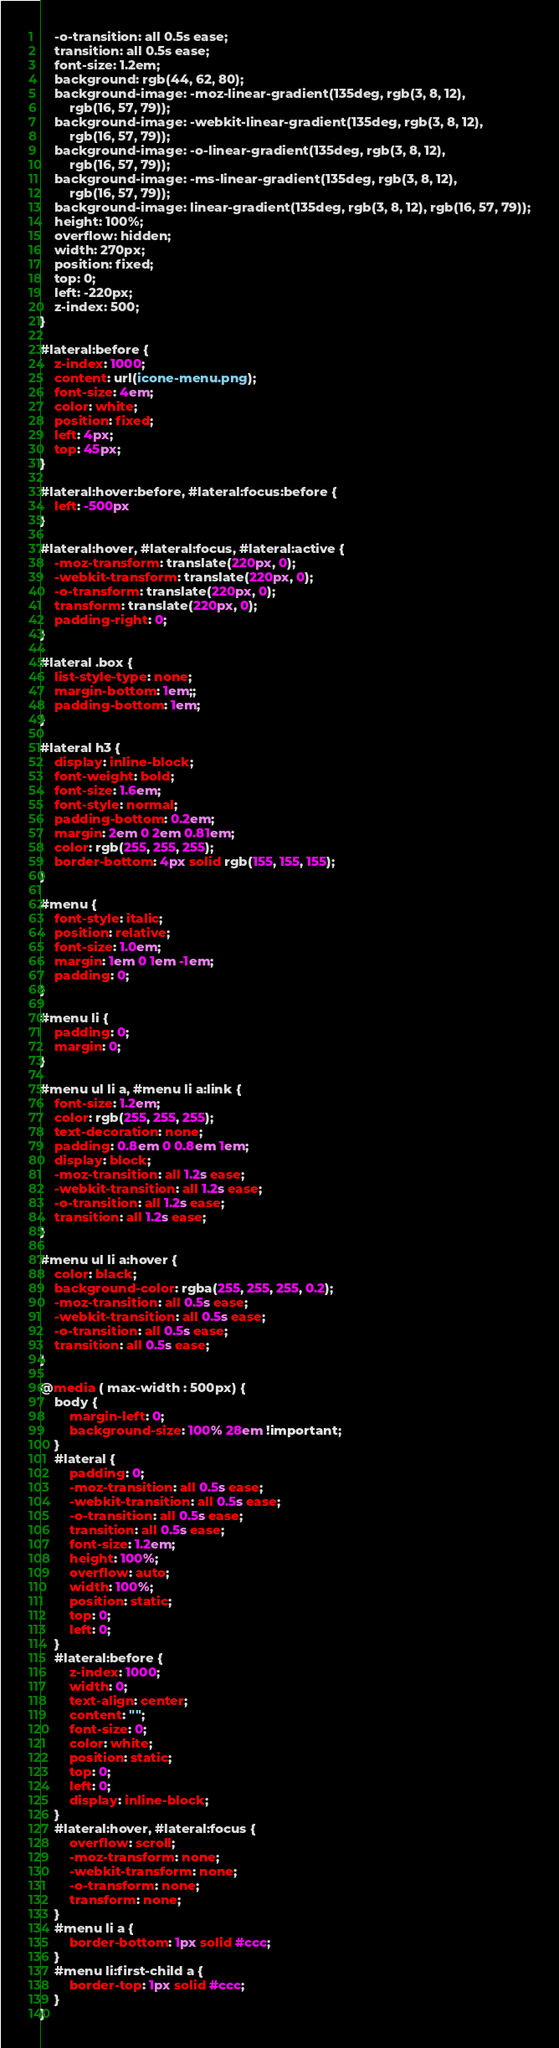Convert code to text. <code><loc_0><loc_0><loc_500><loc_500><_CSS_>	-o-transition: all 0.5s ease;
	transition: all 0.5s ease;
	font-size: 1.2em;
	background: rgb(44, 62, 80);
	background-image: -moz-linear-gradient(135deg, rgb(3, 8, 12),
		rgb(16, 57, 79));
	background-image: -webkit-linear-gradient(135deg, rgb(3, 8, 12),
		rgb(16, 57, 79));
	background-image: -o-linear-gradient(135deg, rgb(3, 8, 12),
		rgb(16, 57, 79));
	background-image: -ms-linear-gradient(135deg, rgb(3, 8, 12),
		rgb(16, 57, 79));
	background-image: linear-gradient(135deg, rgb(3, 8, 12), rgb(16, 57, 79));
	height: 100%;
	overflow: hidden;
	width: 270px;
	position: fixed;
	top: 0;
	left: -220px;
	z-index: 500;
}

#lateral:before {
	z-index: 1000;
	content: url(icone-menu.png);
	font-size: 4em;
	color: white;
	position: fixed;
	left: 4px;
	top: 45px;
}

#lateral:hover:before, #lateral:focus:before {
	left: -500px
}

#lateral:hover, #lateral:focus, #lateral:active {
	-moz-transform: translate(220px, 0);
	-webkit-transform: translate(220px, 0);
	-o-transform: translate(220px, 0);
	transform: translate(220px, 0);
	padding-right: 0;
}

#lateral .box {
	list-style-type: none;
	margin-bottom: 1em;;
	padding-bottom: 1em;
}

#lateral h3 {
	display: inline-block;
	font-weight: bold;
	font-size: 1.6em;
	font-style: normal;
	padding-bottom: 0.2em;
	margin: 2em 0 2em 0.81em;
	color: rgb(255, 255, 255);
	border-bottom: 4px solid rgb(155, 155, 155);
}

#menu {
	font-style: italic;
	position: relative;
	font-size: 1.0em;
	margin: 1em 0 1em -1em;
	padding: 0;
}

#menu li {
	padding: 0;
	margin: 0;
}

#menu ul li a, #menu li a:link {
	font-size: 1.2em;
	color: rgb(255, 255, 255);
	text-decoration: none;
	padding: 0.8em 0 0.8em 1em;
	display: block;
	-moz-transition: all 1.2s ease;
	-webkit-transition: all 1.2s ease;
	-o-transition: all 1.2s ease;
	transition: all 1.2s ease;
}

#menu ul li a:hover {
	color: black;
	background-color: rgba(255, 255, 255, 0.2);
	-moz-transition: all 0.5s ease;
	-webkit-transition: all 0.5s ease;
	-o-transition: all 0.5s ease;
	transition: all 0.5s ease;
}

@media ( max-width : 500px) {
	body {
		margin-left: 0;
		background-size: 100% 28em !important;
	}
	#lateral {
		padding: 0;
		-moz-transition: all 0.5s ease;
		-webkit-transition: all 0.5s ease;
		-o-transition: all 0.5s ease;
		transition: all 0.5s ease;
		font-size: 1.2em;
		height: 100%;
		overflow: auto;
		width: 100%;
		position: static;
		top: 0;
		left: 0;
	}
	#lateral:before {
		z-index: 1000;
		width: 0;
		text-align: center;
		content: "";
		font-size: 0;
		color: white;
		position: static;
		top: 0;
		left: 0;
		display: inline-block;
	}
	#lateral:hover, #lateral:focus {
		overflow: scroll;
		-moz-transform: none;
		-webkit-transform: none;
		-o-transform: none;
		transform: none;
	}
	#menu li a {
		border-bottom: 1px solid #ccc;
	}
	#menu li:first-child a {
		border-top: 1px solid #ccc;
	}
}</code> 